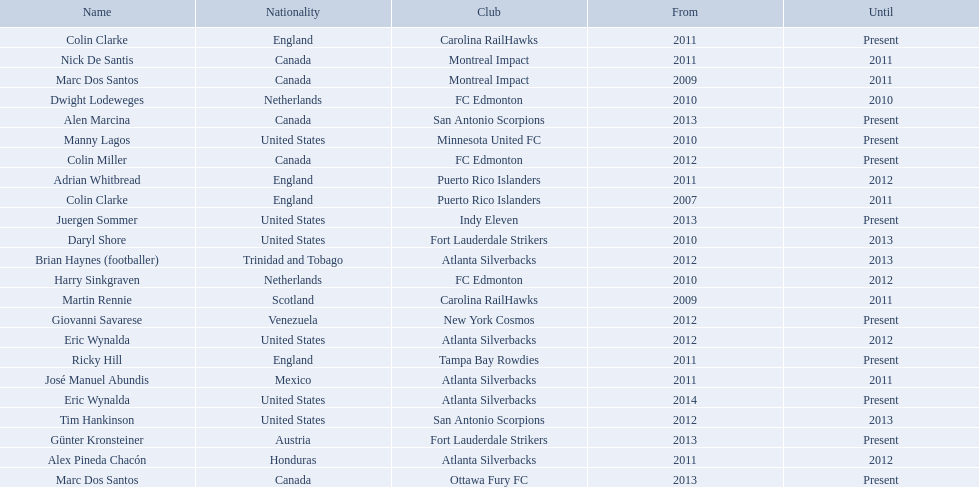What were all the coaches who were coaching in 2010? Martin Rennie, Dwight Lodeweges, Harry Sinkgraven, Daryl Shore, Manny Lagos, Marc Dos Santos, Colin Clarke. Which of the 2010 coaches were not born in north america? Martin Rennie, Dwight Lodeweges, Harry Sinkgraven, Colin Clarke. Which coaches that were coaching in 2010 and were not from north america did not coach for fc edmonton? Martin Rennie, Colin Clarke. What coach did not coach for fc edmonton in 2010 and was not north american nationality had the shortened career as a coach? Martin Rennie. 